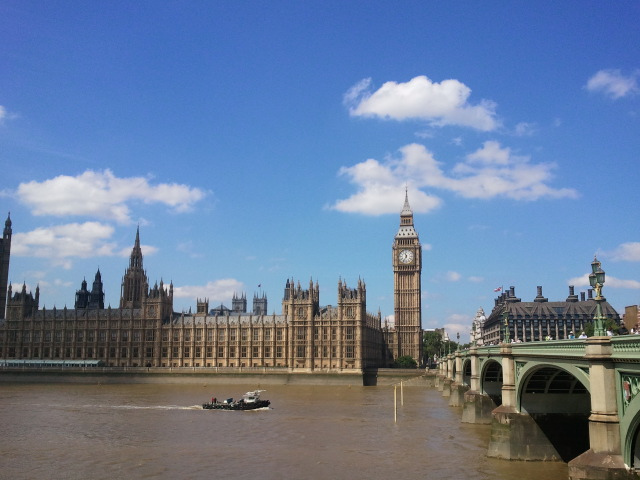<image>What does Big Ben say? I am not sure what time Big Ben says. It could be multiple different times. What does Big Ben say? I don't know what Big Ben says. It can be 'time', 'noon', 'not sure', '10:35', '8:00', '11:35', '12:00' or '6:59'. 